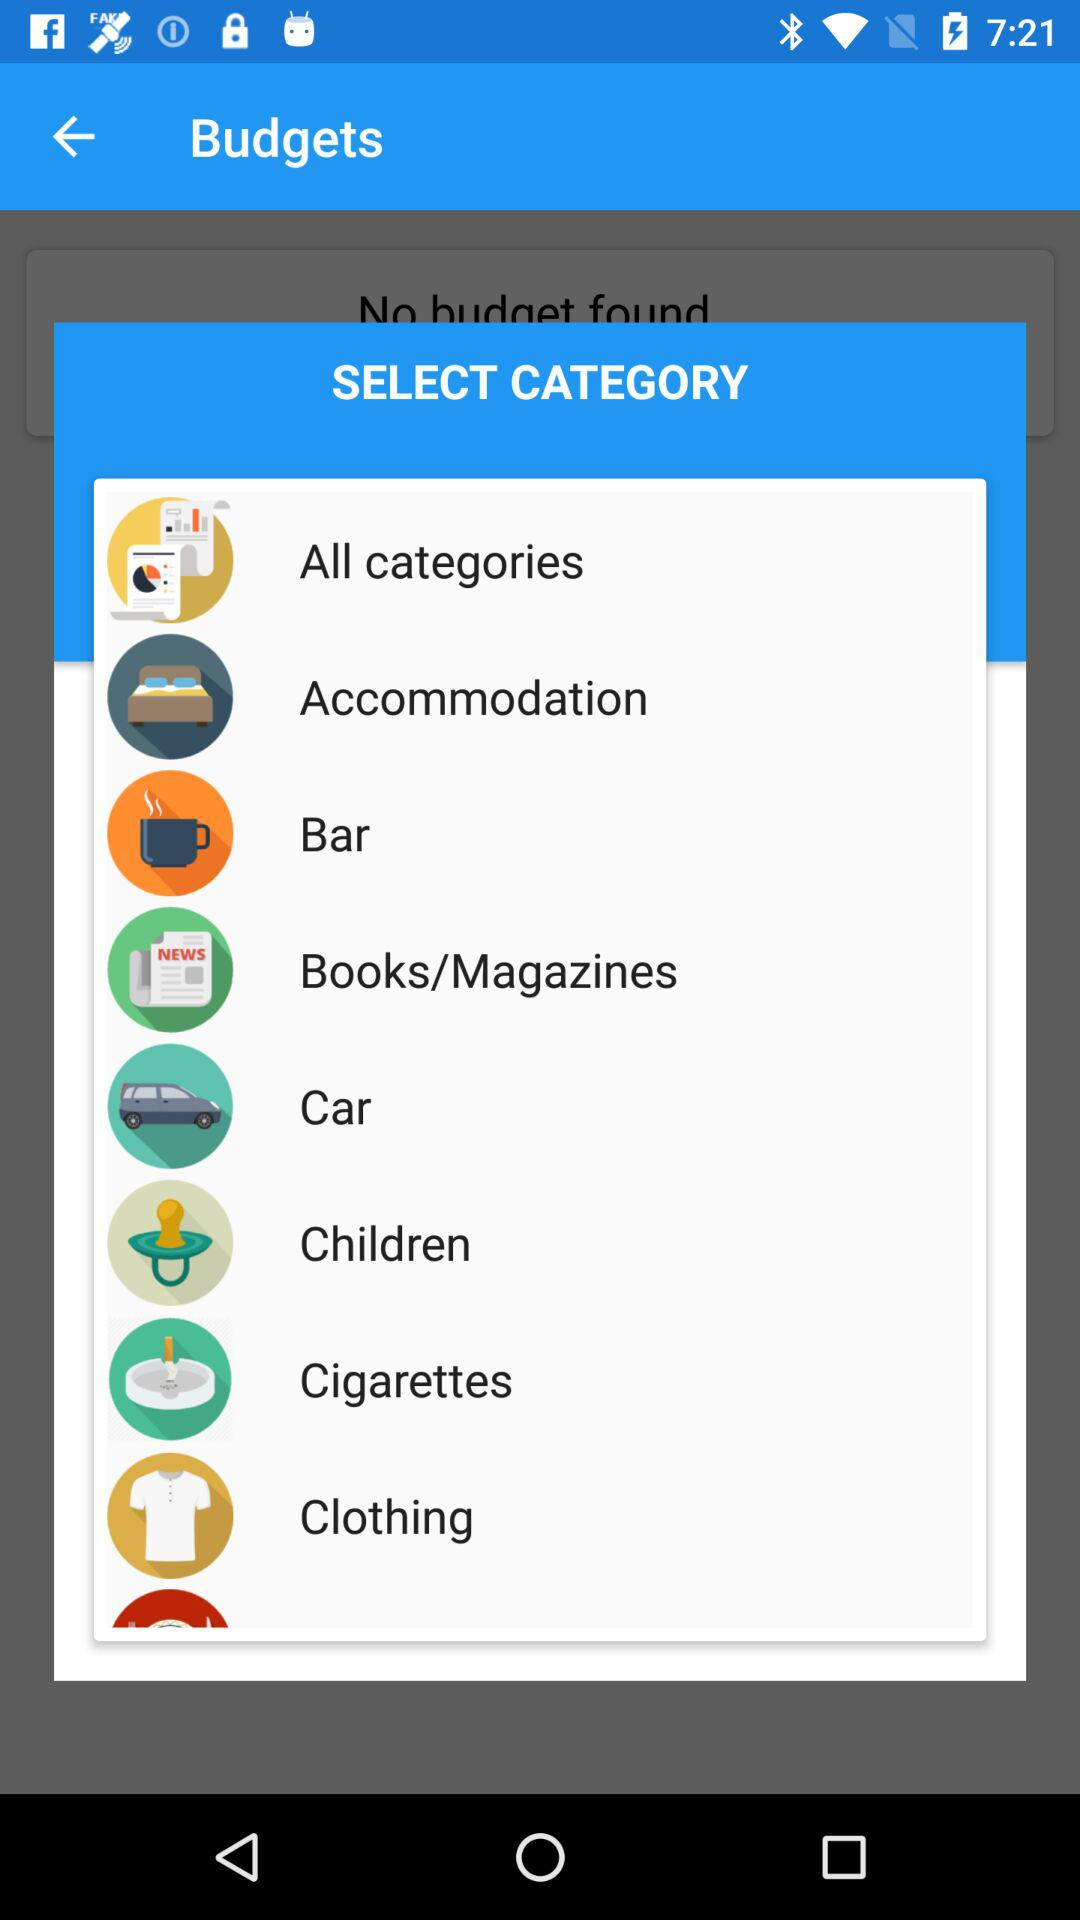How many categories are there?
Answer the question using a single word or phrase. 8 